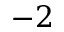<formula> <loc_0><loc_0><loc_500><loc_500>- 2</formula> 